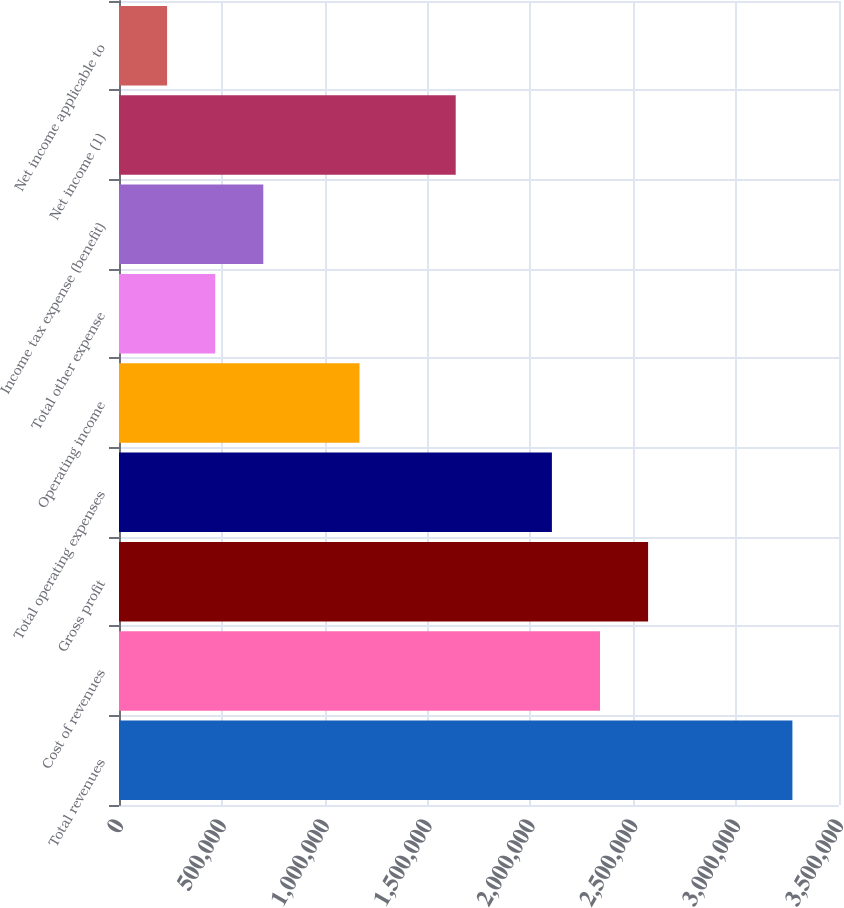Convert chart. <chart><loc_0><loc_0><loc_500><loc_500><bar_chart><fcel>Total revenues<fcel>Cost of revenues<fcel>Gross profit<fcel>Total operating expenses<fcel>Operating income<fcel>Total other expense<fcel>Income tax expense (benefit)<fcel>Net income (1)<fcel>Net income applicable to<nl><fcel>3.27349e+06<fcel>2.33821e+06<fcel>2.57203e+06<fcel>2.10439e+06<fcel>1.16911e+06<fcel>467650<fcel>701471<fcel>1.63675e+06<fcel>233830<nl></chart> 